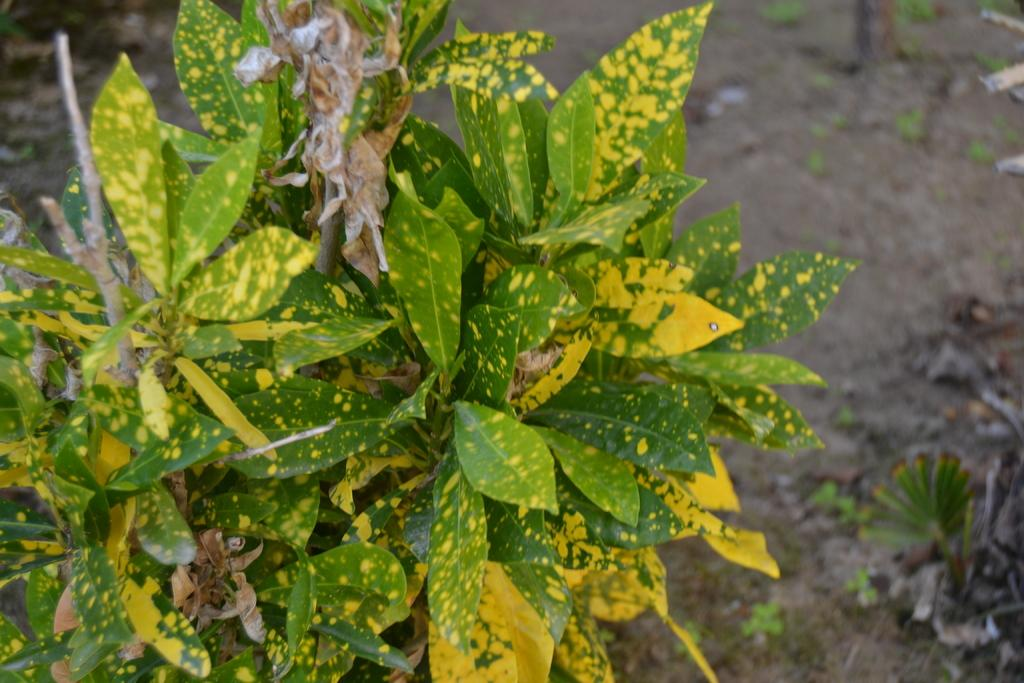What is located in the foreground of the image? There is a plant in the foreground of the image. What colors are the leaves of the plant? The leaves of the plant are in green and yellow colors. Are there any other plants visible in the image? Yes, there are plants on the ground in the image. Can you tell me how many geese are walking on the railway in the image? There is no railway or geese present in the image; it features a plant with green and yellow leaves and other plants on the ground. 